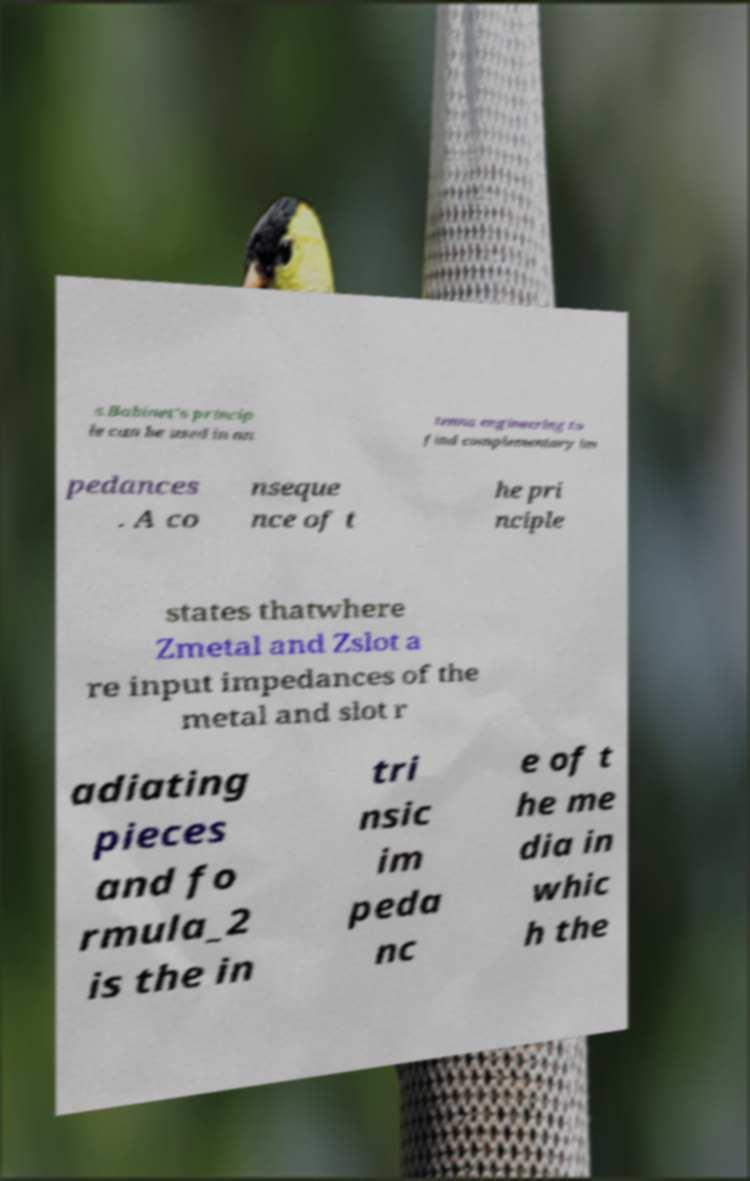Could you extract and type out the text from this image? s.Babinet's princip le can be used in an tenna engineering to find complementary im pedances . A co nseque nce of t he pri nciple states thatwhere Zmetal and Zslot a re input impedances of the metal and slot r adiating pieces and fo rmula_2 is the in tri nsic im peda nc e of t he me dia in whic h the 